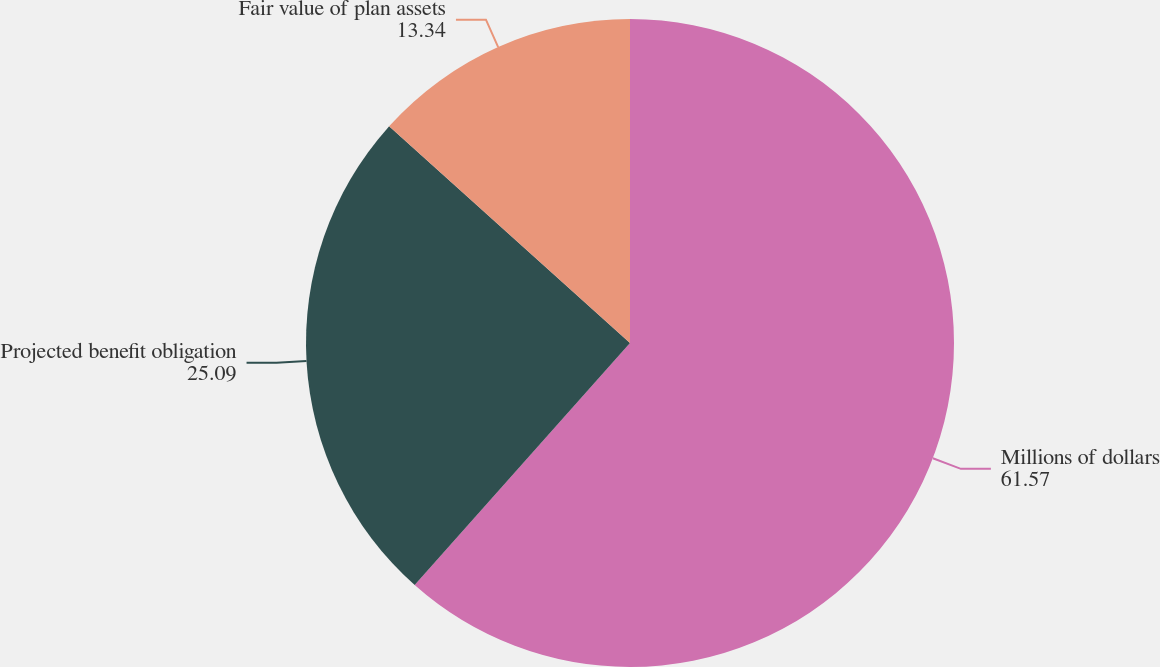Convert chart. <chart><loc_0><loc_0><loc_500><loc_500><pie_chart><fcel>Millions of dollars<fcel>Projected benefit obligation<fcel>Fair value of plan assets<nl><fcel>61.57%<fcel>25.09%<fcel>13.34%<nl></chart> 